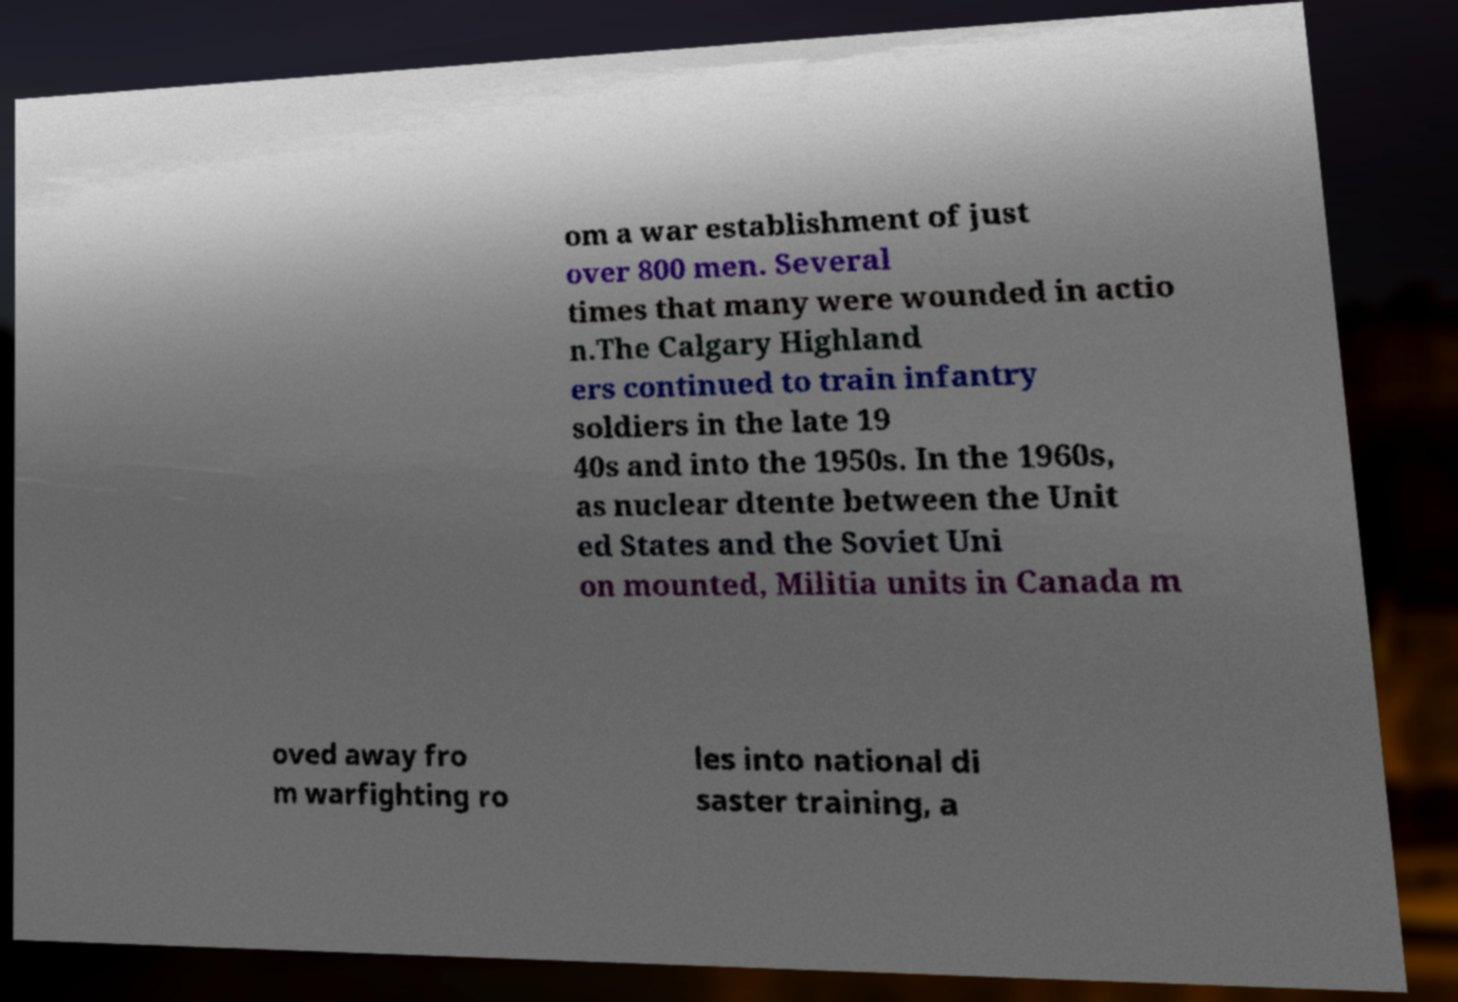I need the written content from this picture converted into text. Can you do that? om a war establishment of just over 800 men. Several times that many were wounded in actio n.The Calgary Highland ers continued to train infantry soldiers in the late 19 40s and into the 1950s. In the 1960s, as nuclear dtente between the Unit ed States and the Soviet Uni on mounted, Militia units in Canada m oved away fro m warfighting ro les into national di saster training, a 